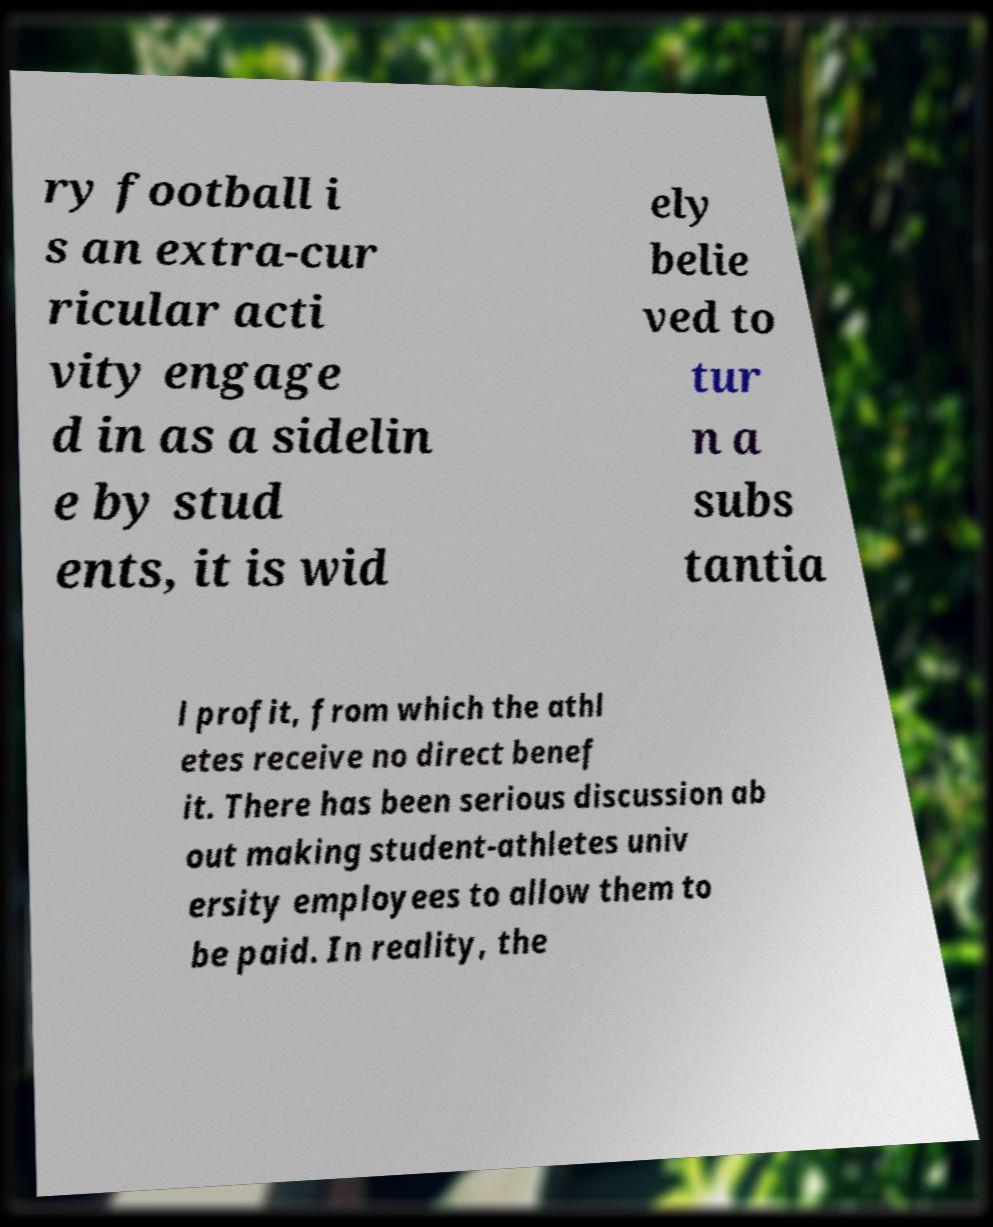Could you extract and type out the text from this image? ry football i s an extra-cur ricular acti vity engage d in as a sidelin e by stud ents, it is wid ely belie ved to tur n a subs tantia l profit, from which the athl etes receive no direct benef it. There has been serious discussion ab out making student-athletes univ ersity employees to allow them to be paid. In reality, the 